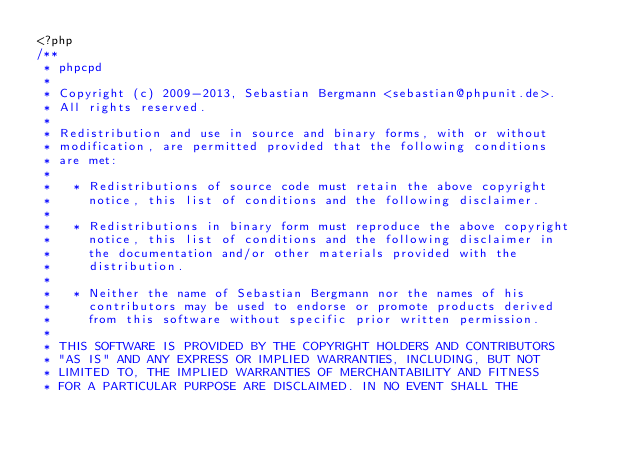Convert code to text. <code><loc_0><loc_0><loc_500><loc_500><_PHP_><?php
/**
 * phpcpd
 *
 * Copyright (c) 2009-2013, Sebastian Bergmann <sebastian@phpunit.de>.
 * All rights reserved.
 *
 * Redistribution and use in source and binary forms, with or without
 * modification, are permitted provided that the following conditions
 * are met:
 *
 *   * Redistributions of source code must retain the above copyright
 *     notice, this list of conditions and the following disclaimer.
 *
 *   * Redistributions in binary form must reproduce the above copyright
 *     notice, this list of conditions and the following disclaimer in
 *     the documentation and/or other materials provided with the
 *     distribution.
 *
 *   * Neither the name of Sebastian Bergmann nor the names of his
 *     contributors may be used to endorse or promote products derived
 *     from this software without specific prior written permission.
 *
 * THIS SOFTWARE IS PROVIDED BY THE COPYRIGHT HOLDERS AND CONTRIBUTORS
 * "AS IS" AND ANY EXPRESS OR IMPLIED WARRANTIES, INCLUDING, BUT NOT
 * LIMITED TO, THE IMPLIED WARRANTIES OF MERCHANTABILITY AND FITNESS
 * FOR A PARTICULAR PURPOSE ARE DISCLAIMED. IN NO EVENT SHALL THE</code> 